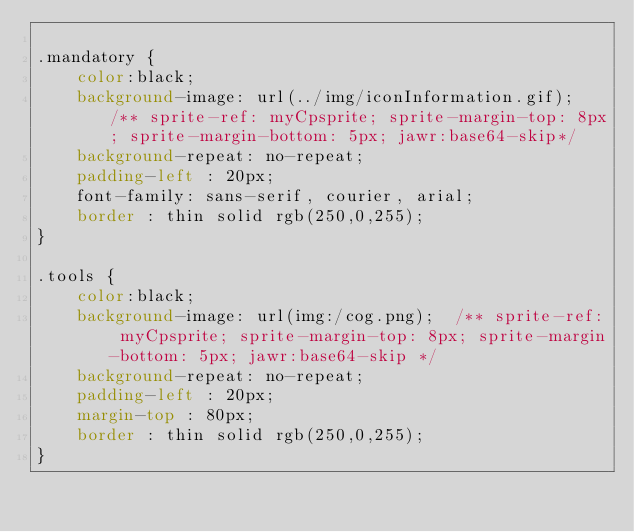<code> <loc_0><loc_0><loc_500><loc_500><_CSS_>
.mandatory { 
	color:black;
	background-image: url(../img/iconInformation.gif);  /** sprite-ref: myCpsprite; sprite-margin-top: 8px; sprite-margin-bottom: 5px; jawr:base64-skip*/
	background-repeat: no-repeat;
	padding-left : 20px;
	font-family: sans-serif, courier, arial;
	border : thin solid rgb(250,0,255);
}

.tools { 
	color:black;
	background-image: url(img:/cog.png);  /** sprite-ref: myCpsprite; sprite-margin-top: 8px; sprite-margin-bottom: 5px; jawr:base64-skip */
	background-repeat: no-repeat;
	padding-left : 20px;
	margin-top : 80px;
	border : thin solid rgb(250,0,255);
}
</code> 